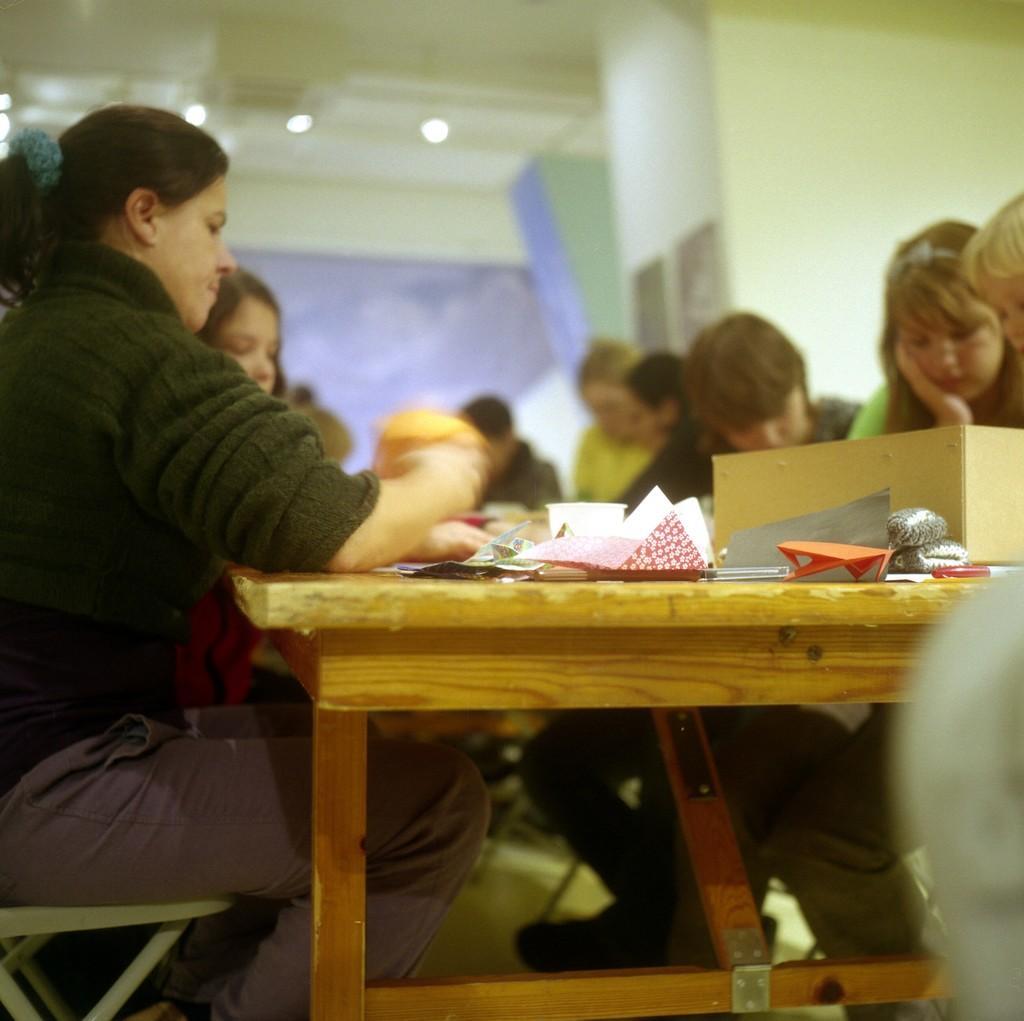Can you describe this image briefly? In this image we can see people sitting on the chairs near the table. We can see few things placed on the table. 